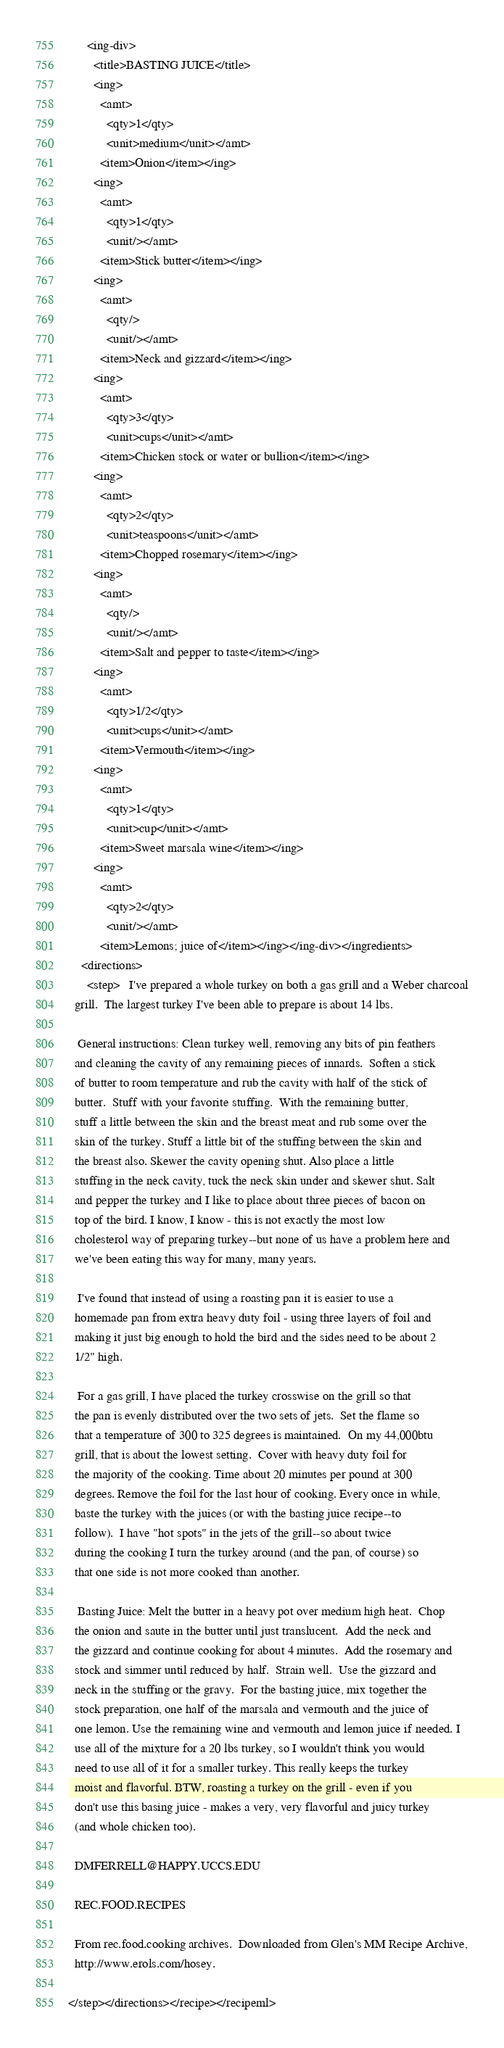<code> <loc_0><loc_0><loc_500><loc_500><_XML_>      <ing-div>
        <title>BASTING JUICE</title>
        <ing>
          <amt>
            <qty>1</qty>
            <unit>medium</unit></amt>
          <item>Onion</item></ing>
        <ing>
          <amt>
            <qty>1</qty>
            <unit/></amt>
          <item>Stick butter</item></ing>
        <ing>
          <amt>
            <qty/>
            <unit/></amt>
          <item>Neck and gizzard</item></ing>
        <ing>
          <amt>
            <qty>3</qty>
            <unit>cups</unit></amt>
          <item>Chicken stock or water or bullion</item></ing>
        <ing>
          <amt>
            <qty>2</qty>
            <unit>teaspoons</unit></amt>
          <item>Chopped rosemary</item></ing>
        <ing>
          <amt>
            <qty/>
            <unit/></amt>
          <item>Salt and pepper to taste</item></ing>
        <ing>
          <amt>
            <qty>1/2</qty>
            <unit>cups</unit></amt>
          <item>Vermouth</item></ing>
        <ing>
          <amt>
            <qty>1</qty>
            <unit>cup</unit></amt>
          <item>Sweet marsala wine</item></ing>
        <ing>
          <amt>
            <qty>2</qty>
            <unit/></amt>
          <item>Lemons; juice of</item></ing></ing-div></ingredients>
    <directions>
      <step>   I've prepared a whole turkey on both a gas grill and a Weber charcoal
  grill.  The largest turkey I've been able to prepare is about 14 lbs.
  
   General instructions: Clean turkey well, removing any bits of pin feathers
  and cleaning the cavity of any remaining pieces of innards.  Soften a stick
  of butter to room temperature and rub the cavity with half of the stick of
  butter.  Stuff with your favorite stuffing.  With the remaining butter,
  stuff a little between the skin and the breast meat and rub some over the
  skin of the turkey. Stuff a little bit of the stuffing between the skin and
  the breast also. Skewer the cavity opening shut. Also place a little
  stuffing in the neck cavity, tuck the neck skin under and skewer shut. Salt
  and pepper the turkey and I like to place about three pieces of bacon on
  top of the bird. I know, I know - this is not exactly the most low
  cholesterol way of preparing turkey--but none of us have a problem here and
  we've been eating this way for many, many years.
  
   I've found that instead of using a roasting pan it is easier to use a
  homemade pan from extra heavy duty foil - using three layers of foil and
  making it just big enough to hold the bird and the sides need to be about 2
  1/2" high.
  
   For a gas grill, I have placed the turkey crosswise on the grill so that
  the pan is evenly distributed over the two sets of jets.  Set the flame so
  that a temperature of 300 to 325 degrees is maintained.  On my 44,000btu
  grill, that is about the lowest setting.  Cover with heavy duty foil for
  the majority of the cooking. Time about 20 minutes per pound at 300
  degrees. Remove the foil for the last hour of cooking. Every once in while,
  baste the turkey with the juices (or with the basting juice recipe--to
  follow).  I have "hot spots" in the jets of the grill--so about twice
  during the cooking I turn the turkey around (and the pan, of course) so
  that one side is not more cooked than another.
  
   Basting Juice: Melt the butter in a heavy pot over medium high heat.  Chop
  the onion and saute in the butter until just translucent.  Add the neck and
  the gizzard and continue cooking for about 4 minutes.  Add the rosemary and
  stock and simmer until reduced by half.  Strain well.  Use the gizzard and
  neck in the stuffing or the gravy.  For the basting juice, mix together the
  stock preparation, one half of the marsala and vermouth and the juice of
  one lemon. Use the remaining wine and vermouth and lemon juice if needed. I
  use all of the mixture for a 20 lbs turkey, so I wouldn't think you would
  need to use all of it for a smaller turkey. This really keeps the turkey
  moist and flavorful. BTW, roasting a turkey on the grill - even if you
  don't use this basing juice - makes a very, very flavorful and juicy turkey
  (and whole chicken too).
  
  DMFERRELL@HAPPY.UCCS.EDU
  
  REC.FOOD.RECIPES
  
  From rec.food.cooking archives.  Downloaded from Glen's MM Recipe Archive,
  http://www.erols.com/hosey.
 
</step></directions></recipe></recipeml>
</code> 